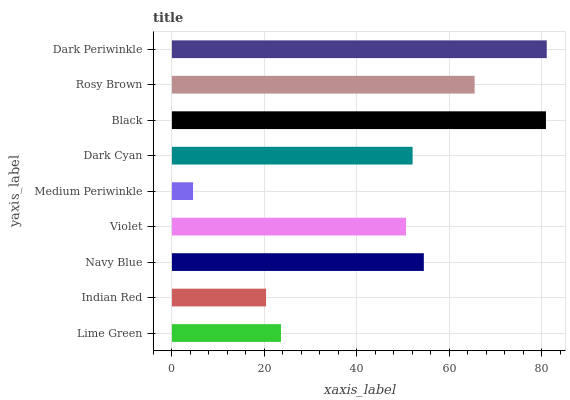Is Medium Periwinkle the minimum?
Answer yes or no. Yes. Is Dark Periwinkle the maximum?
Answer yes or no. Yes. Is Indian Red the minimum?
Answer yes or no. No. Is Indian Red the maximum?
Answer yes or no. No. Is Lime Green greater than Indian Red?
Answer yes or no. Yes. Is Indian Red less than Lime Green?
Answer yes or no. Yes. Is Indian Red greater than Lime Green?
Answer yes or no. No. Is Lime Green less than Indian Red?
Answer yes or no. No. Is Dark Cyan the high median?
Answer yes or no. Yes. Is Dark Cyan the low median?
Answer yes or no. Yes. Is Navy Blue the high median?
Answer yes or no. No. Is Medium Periwinkle the low median?
Answer yes or no. No. 